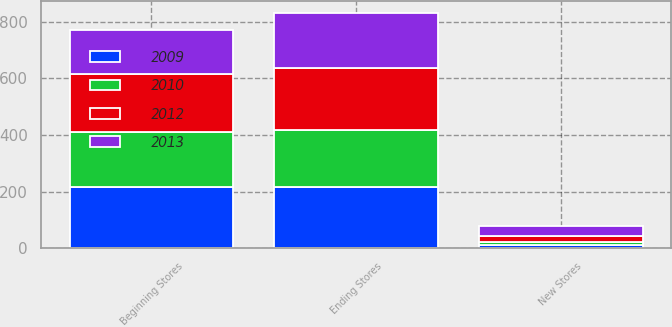Convert chart. <chart><loc_0><loc_0><loc_500><loc_500><stacked_bar_chart><ecel><fcel>Beginning Stores<fcel>New Stores<fcel>Ending Stores<nl><fcel>2009<fcel>218<fcel>12<fcel>217<nl><fcel>2012<fcel>202<fcel>21<fcel>218<nl><fcel>2010<fcel>194<fcel>9<fcel>202<nl><fcel>2013<fcel>156<fcel>38<fcel>194<nl></chart> 